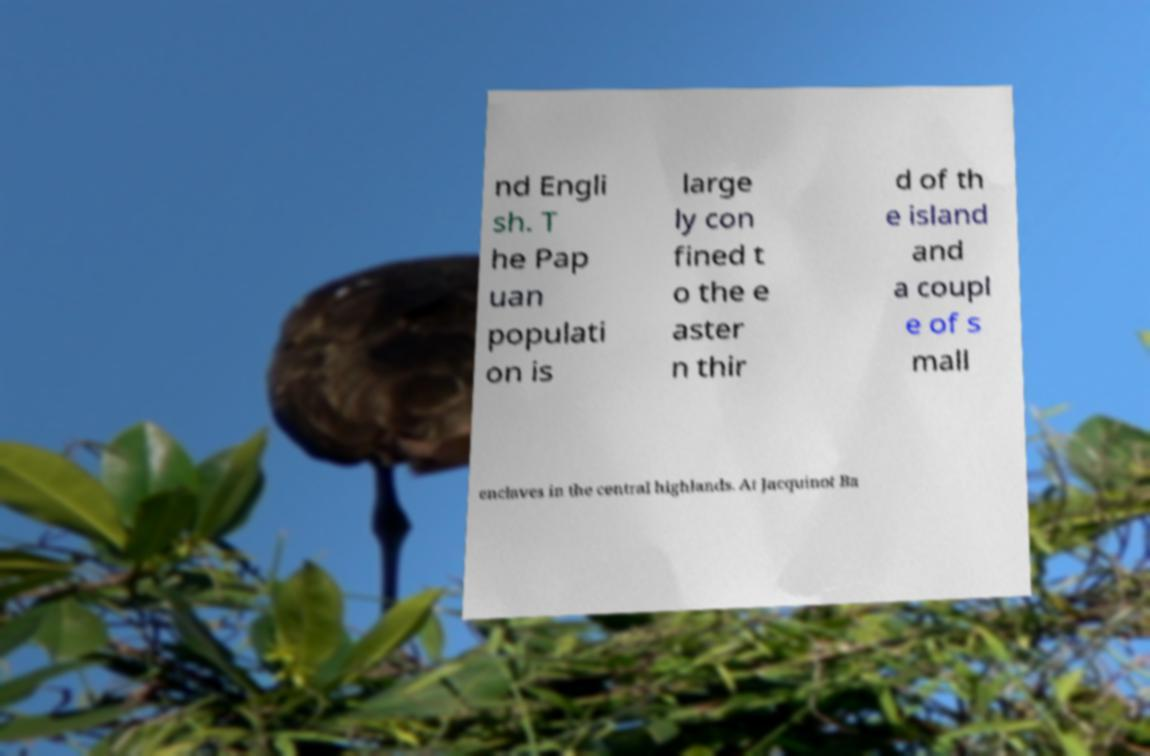Please read and relay the text visible in this image. What does it say? nd Engli sh. T he Pap uan populati on is large ly con fined t o the e aster n thir d of th e island and a coupl e of s mall enclaves in the central highlands. At Jacquinot Ba 